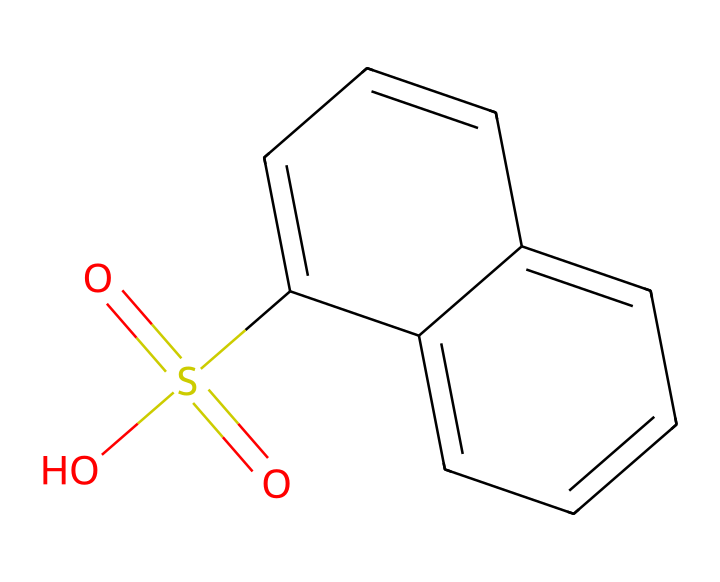What is the core structure of this compound? The core structure is naphthalene, which consists of two fused benzene rings. The SMILES representation shows multiple aromatic rings, confirming the presence of naphthalene.
Answer: naphthalene How many sulfur atoms are in this structure? The SMILES shows "S(=O)(=O)", which indicates the presence of one sulfur atom connected to two oxygen atoms in a sulfonic acid group (–SO3H).
Answer: one What type of functional group is present in this compound? The presence of "S(=O)(=O)O" indicates a sulfonic acid group (-SO3H), which is characteristic of sulfonates in aromatic compounds.
Answer: sulfonic acid What is the total number of carbon atoms in the structure? By analyzing the structure, we can count the number of carbon atoms in the rings and the -SO3H group. There are ten carbon atoms from the naphthalene portion.
Answer: ten How many rings are present in this chemical structure? The first part of the SMILES "c1ccc2c(c1)cccc2" indicates that there are two fused rings formed by the carbon atoms, characteristic of naphthalene.
Answer: two Does this compound have any hydroxyl (-OH) groups? The SMILES does not include any "O" connected directly to hydrogen (such as the -OH representation); it only includes the sulfonic acid group, confirming that there are no hydroxyl groups.
Answer: no 